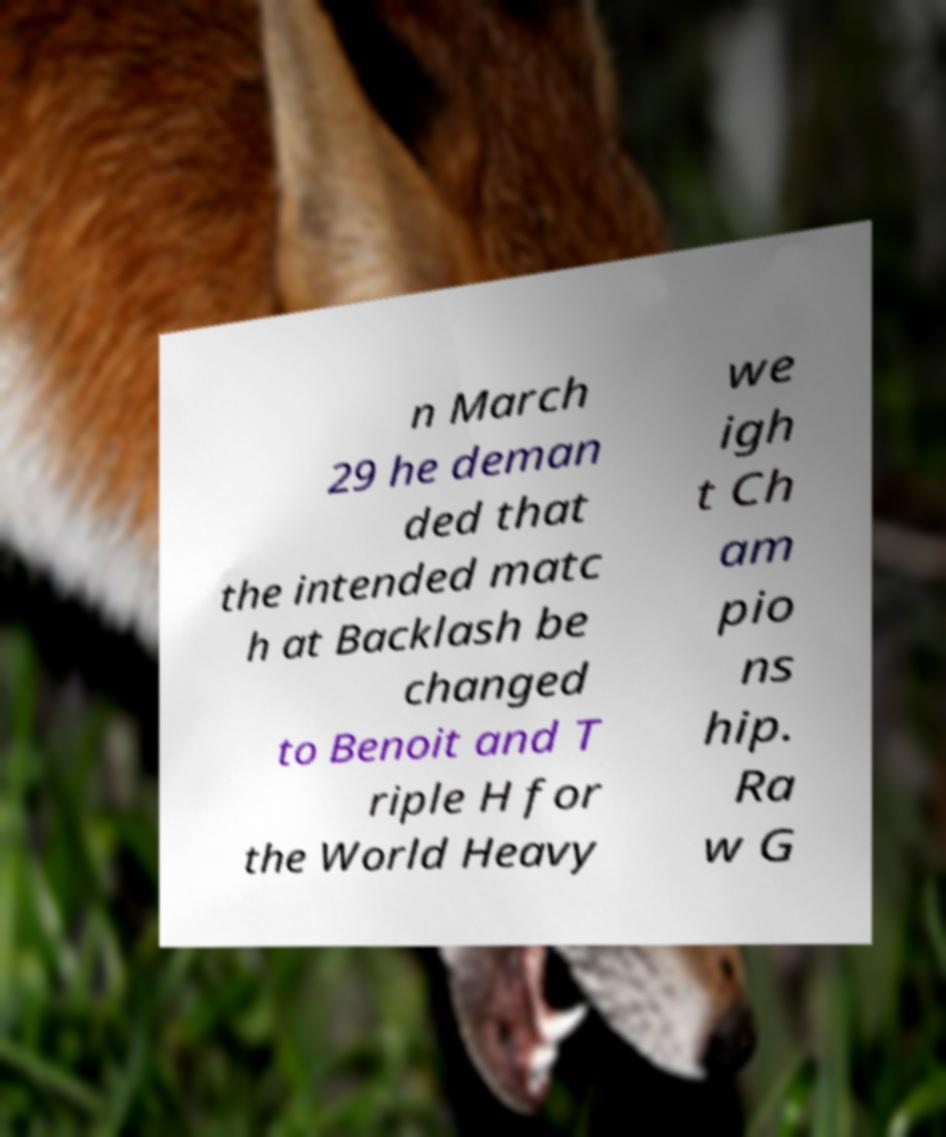For documentation purposes, I need the text within this image transcribed. Could you provide that? n March 29 he deman ded that the intended matc h at Backlash be changed to Benoit and T riple H for the World Heavy we igh t Ch am pio ns hip. Ra w G 